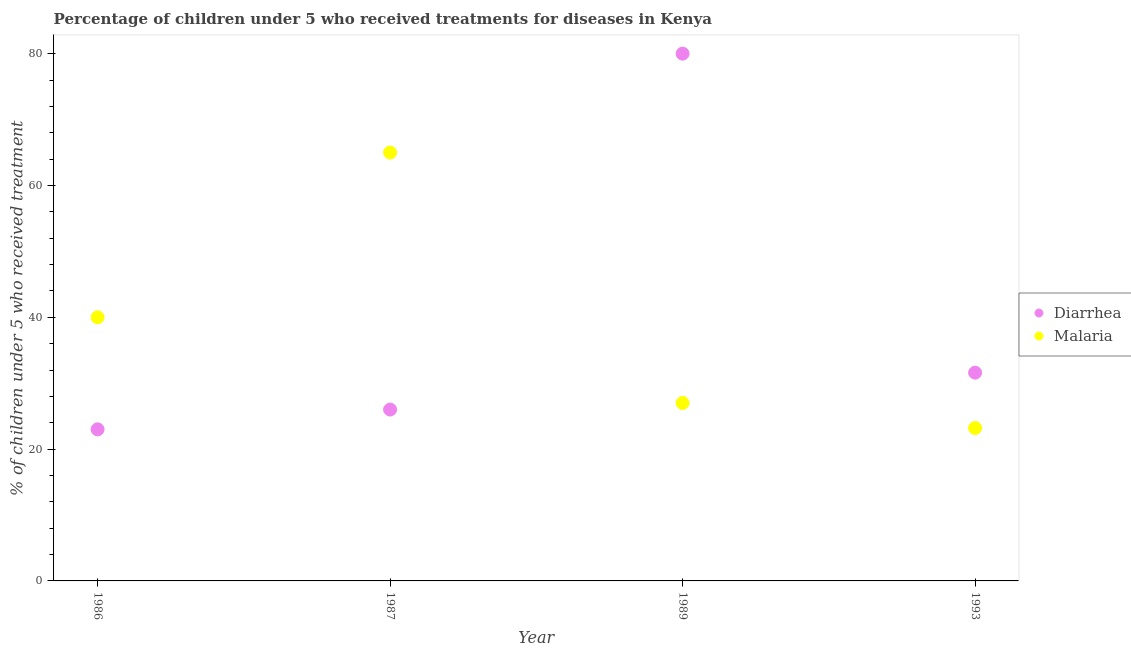How many different coloured dotlines are there?
Make the answer very short. 2. What is the percentage of children who received treatment for malaria in 1987?
Offer a terse response. 65. In which year was the percentage of children who received treatment for malaria maximum?
Offer a terse response. 1987. In which year was the percentage of children who received treatment for diarrhoea minimum?
Give a very brief answer. 1986. What is the total percentage of children who received treatment for diarrhoea in the graph?
Keep it short and to the point. 160.6. What is the difference between the percentage of children who received treatment for diarrhoea in 1993 and the percentage of children who received treatment for malaria in 1986?
Make the answer very short. -8.4. What is the average percentage of children who received treatment for malaria per year?
Provide a succinct answer. 38.8. In the year 1986, what is the difference between the percentage of children who received treatment for malaria and percentage of children who received treatment for diarrhoea?
Give a very brief answer. 17. In how many years, is the percentage of children who received treatment for malaria greater than 60 %?
Provide a short and direct response. 1. What is the ratio of the percentage of children who received treatment for malaria in 1986 to that in 1989?
Provide a succinct answer. 1.48. Is the percentage of children who received treatment for diarrhoea in 1987 less than that in 1993?
Provide a short and direct response. Yes. Is the difference between the percentage of children who received treatment for diarrhoea in 1986 and 1989 greater than the difference between the percentage of children who received treatment for malaria in 1986 and 1989?
Provide a succinct answer. No. What is the difference between the highest and the lowest percentage of children who received treatment for diarrhoea?
Give a very brief answer. 57. In how many years, is the percentage of children who received treatment for diarrhoea greater than the average percentage of children who received treatment for diarrhoea taken over all years?
Your response must be concise. 1. Does the percentage of children who received treatment for diarrhoea monotonically increase over the years?
Provide a short and direct response. No. Is the percentage of children who received treatment for malaria strictly greater than the percentage of children who received treatment for diarrhoea over the years?
Keep it short and to the point. No. Is the percentage of children who received treatment for malaria strictly less than the percentage of children who received treatment for diarrhoea over the years?
Your response must be concise. No. How many dotlines are there?
Offer a terse response. 2. What is the difference between two consecutive major ticks on the Y-axis?
Your answer should be compact. 20. Does the graph contain any zero values?
Ensure brevity in your answer.  No. Where does the legend appear in the graph?
Ensure brevity in your answer.  Center right. How are the legend labels stacked?
Offer a very short reply. Vertical. What is the title of the graph?
Offer a terse response. Percentage of children under 5 who received treatments for diseases in Kenya. Does "Excluding technical cooperation" appear as one of the legend labels in the graph?
Your answer should be very brief. No. What is the label or title of the Y-axis?
Your answer should be compact. % of children under 5 who received treatment. What is the % of children under 5 who received treatment in Diarrhea in 1986?
Keep it short and to the point. 23. What is the % of children under 5 who received treatment of Malaria in 1986?
Offer a very short reply. 40. What is the % of children under 5 who received treatment of Malaria in 1987?
Provide a succinct answer. 65. What is the % of children under 5 who received treatment in Malaria in 1989?
Your answer should be very brief. 27. What is the % of children under 5 who received treatment of Diarrhea in 1993?
Offer a terse response. 31.6. What is the % of children under 5 who received treatment of Malaria in 1993?
Give a very brief answer. 23.2. Across all years, what is the maximum % of children under 5 who received treatment in Diarrhea?
Ensure brevity in your answer.  80. Across all years, what is the maximum % of children under 5 who received treatment of Malaria?
Your answer should be compact. 65. Across all years, what is the minimum % of children under 5 who received treatment of Diarrhea?
Provide a succinct answer. 23. Across all years, what is the minimum % of children under 5 who received treatment of Malaria?
Provide a succinct answer. 23.2. What is the total % of children under 5 who received treatment in Diarrhea in the graph?
Provide a succinct answer. 160.6. What is the total % of children under 5 who received treatment in Malaria in the graph?
Offer a very short reply. 155.2. What is the difference between the % of children under 5 who received treatment in Diarrhea in 1986 and that in 1989?
Give a very brief answer. -57. What is the difference between the % of children under 5 who received treatment of Diarrhea in 1986 and that in 1993?
Provide a succinct answer. -8.6. What is the difference between the % of children under 5 who received treatment in Diarrhea in 1987 and that in 1989?
Provide a short and direct response. -54. What is the difference between the % of children under 5 who received treatment in Malaria in 1987 and that in 1989?
Offer a very short reply. 38. What is the difference between the % of children under 5 who received treatment of Malaria in 1987 and that in 1993?
Your response must be concise. 41.8. What is the difference between the % of children under 5 who received treatment in Diarrhea in 1989 and that in 1993?
Your response must be concise. 48.4. What is the difference between the % of children under 5 who received treatment in Diarrhea in 1986 and the % of children under 5 who received treatment in Malaria in 1987?
Make the answer very short. -42. What is the difference between the % of children under 5 who received treatment of Diarrhea in 1986 and the % of children under 5 who received treatment of Malaria in 1989?
Your response must be concise. -4. What is the difference between the % of children under 5 who received treatment in Diarrhea in 1986 and the % of children under 5 who received treatment in Malaria in 1993?
Give a very brief answer. -0.2. What is the difference between the % of children under 5 who received treatment in Diarrhea in 1987 and the % of children under 5 who received treatment in Malaria in 1989?
Ensure brevity in your answer.  -1. What is the difference between the % of children under 5 who received treatment of Diarrhea in 1987 and the % of children under 5 who received treatment of Malaria in 1993?
Your answer should be very brief. 2.8. What is the difference between the % of children under 5 who received treatment in Diarrhea in 1989 and the % of children under 5 who received treatment in Malaria in 1993?
Your answer should be very brief. 56.8. What is the average % of children under 5 who received treatment of Diarrhea per year?
Provide a short and direct response. 40.15. What is the average % of children under 5 who received treatment in Malaria per year?
Keep it short and to the point. 38.8. In the year 1987, what is the difference between the % of children under 5 who received treatment in Diarrhea and % of children under 5 who received treatment in Malaria?
Your answer should be very brief. -39. What is the ratio of the % of children under 5 who received treatment of Diarrhea in 1986 to that in 1987?
Offer a terse response. 0.88. What is the ratio of the % of children under 5 who received treatment of Malaria in 1986 to that in 1987?
Your response must be concise. 0.62. What is the ratio of the % of children under 5 who received treatment in Diarrhea in 1986 to that in 1989?
Your answer should be compact. 0.29. What is the ratio of the % of children under 5 who received treatment in Malaria in 1986 to that in 1989?
Make the answer very short. 1.48. What is the ratio of the % of children under 5 who received treatment of Diarrhea in 1986 to that in 1993?
Your answer should be compact. 0.73. What is the ratio of the % of children under 5 who received treatment in Malaria in 1986 to that in 1993?
Make the answer very short. 1.72. What is the ratio of the % of children under 5 who received treatment of Diarrhea in 1987 to that in 1989?
Ensure brevity in your answer.  0.33. What is the ratio of the % of children under 5 who received treatment of Malaria in 1987 to that in 1989?
Make the answer very short. 2.41. What is the ratio of the % of children under 5 who received treatment of Diarrhea in 1987 to that in 1993?
Your answer should be compact. 0.82. What is the ratio of the % of children under 5 who received treatment of Malaria in 1987 to that in 1993?
Ensure brevity in your answer.  2.8. What is the ratio of the % of children under 5 who received treatment in Diarrhea in 1989 to that in 1993?
Your answer should be very brief. 2.53. What is the ratio of the % of children under 5 who received treatment in Malaria in 1989 to that in 1993?
Offer a terse response. 1.16. What is the difference between the highest and the second highest % of children under 5 who received treatment in Diarrhea?
Your answer should be very brief. 48.4. What is the difference between the highest and the lowest % of children under 5 who received treatment of Diarrhea?
Keep it short and to the point. 57. What is the difference between the highest and the lowest % of children under 5 who received treatment of Malaria?
Keep it short and to the point. 41.8. 